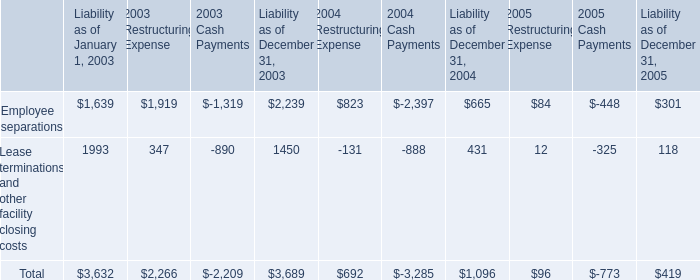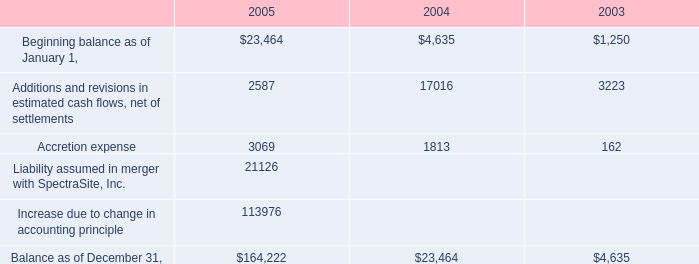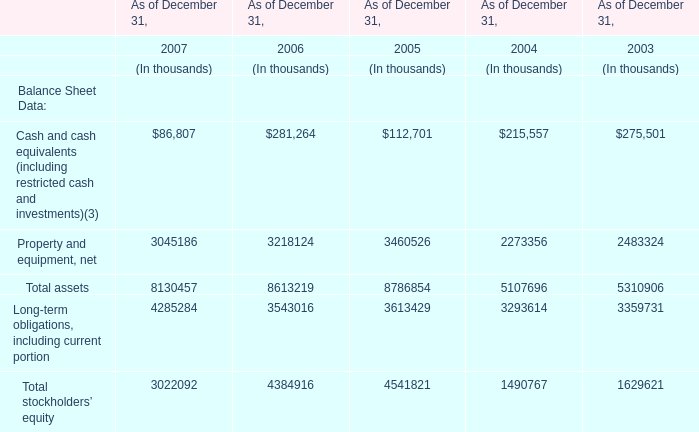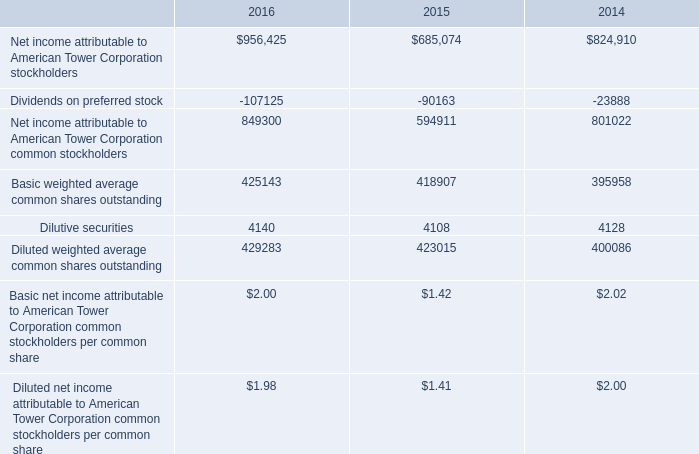what is the percentage change in impairment charges and net losses from 2004 to 2005? 
Computations: ((16.8 - 17.7) / 17.7)
Answer: -0.05085. 